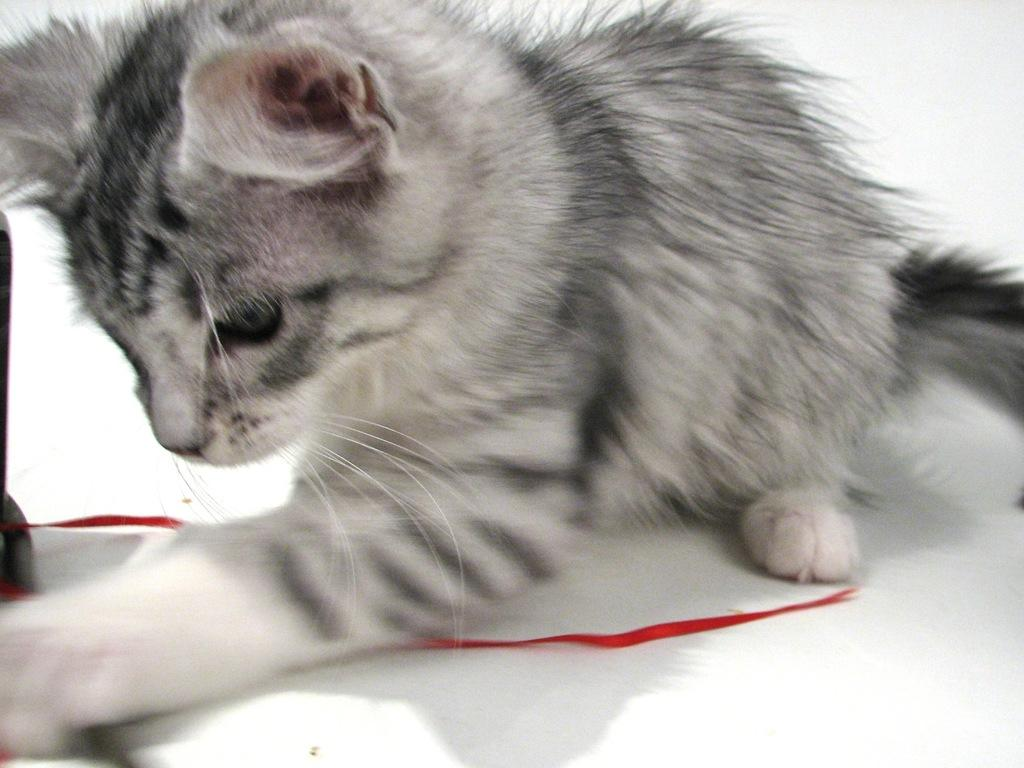What type of animal is in the picture? There is a cat in the picture. What is the color of the ribbon in the picture? There is a red color ribbon in the picture. What type of experience does the cat have with waste management in the picture? There is no indication of waste management or any experience related to it in the picture; it simply features a cat and a red ribbon. 